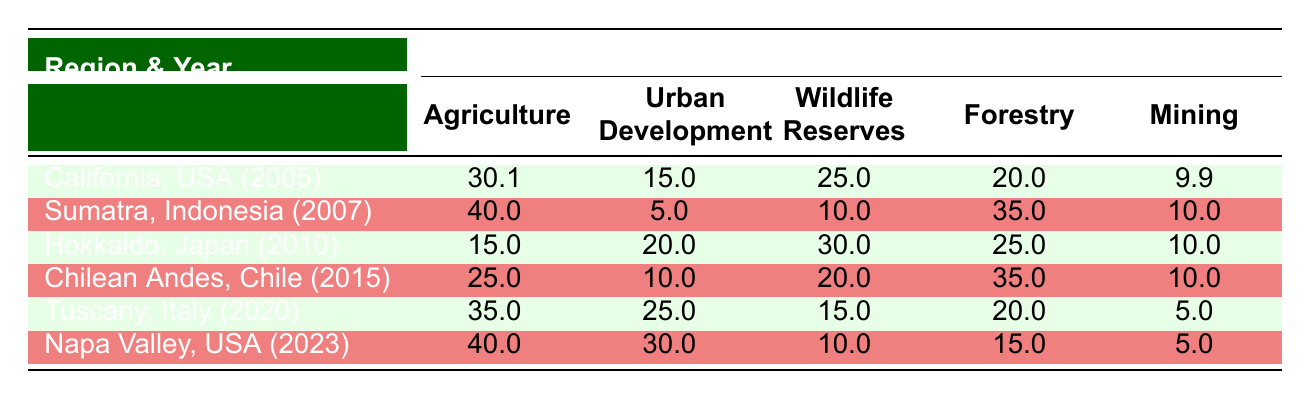What was the percentage of agriculture in California, USA in 2005? From the table, we can see that in California, USA, the land use for agriculture in 2005 is listed directly under that region's row. The value for agriculture in that year is 30.1.
Answer: 30.1 Which region had the highest percentage of mining in the table? By examining the mining percentages across the regions, California (2005) has 9.9, Sumatra (2007) has 10.0, Hokkaido (2010) has 10.0, Chilean Andes (2015) has 10.0, Tuscany (2020) has 5.0, and Napa Valley (2023) has 5.0. The highest percentage is 10.0, found in both Sumatra and Hokkaido.
Answer: Sumatra and Hokkaido What is the total percentage for wildlife reserves across all regions in the table? The wildlife reserves percentages are 25.0 (California, 2005) + 10.0 (Sumatra, 2007) + 30.0 (Hokkaido, 2010) + 20.0 (Chilean Andes, 2015) + 15.0 (Tuscany, 2020) + 10.0 (Napa Valley, 2023). Summing these gives us 25.0 + 10.0 + 30.0 + 20.0 + 15.0 + 10.0 = 110.0.
Answer: 110.0 Is it true that Napa Valley had a higher percentage of urban development than Tuscany? Looking at the urban development percentages: Napa Valley (2023) is 30.0, while Tuscany (2020) is 25.0. Since 30.0 is greater than 25.0, it is true that Napa Valley had higher urban development.
Answer: Yes What is the average percentage of mining for all regions listed in the table? The mining percentages are: 9.9 (California, 2005), 10.0 (Sumatra, 2007), 10.0 (Hokkaido, 2010), 10.0 (Chilean Andes, 2015), 5.0 (Tuscany, 2020), and 5.0 (Napa Valley, 2023). To find the average, we first sum them: 9.9 + 10.0 + 10.0 + 10.0 + 5.0 + 5.0 = 49.9. There are 6 regions, so we divide: 49.9 / 6 ≈ 8.32.
Answer: 8.32 